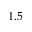<formula> <loc_0><loc_0><loc_500><loc_500>1 . 5</formula> 